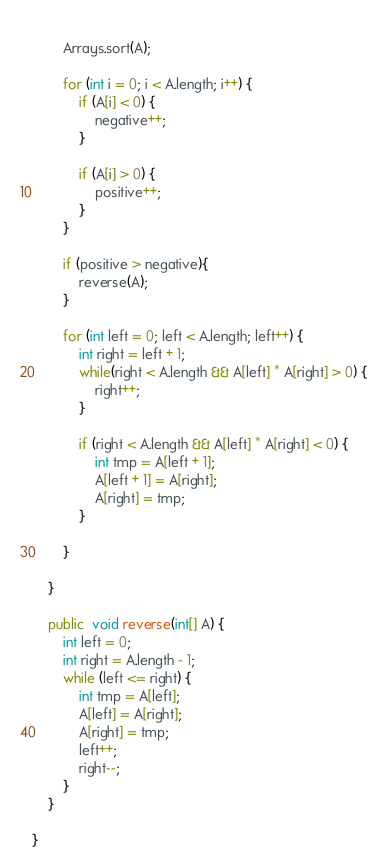<code> <loc_0><loc_0><loc_500><loc_500><_Java_>        
        Arrays.sort(A);

        for (int i = 0; i < A.length; i++) {
            if (A[i] < 0) {
                negative++;
            }

            if (A[i] > 0) {
                positive++;
            }
        }
        
        if (positive > negative){
            reverse(A);
        }

        for (int left = 0; left < A.length; left++) {
            int right = left + 1;
            while(right < A.length && A[left] * A[right] > 0) {
                right++;
            }
            
            if (right < A.length && A[left] * A[right] < 0) {
                int tmp = A[left + 1];
                A[left + 1] = A[right];
                A[right] = tmp;
            }

        }

    }

    public  void reverse(int[] A) {
        int left = 0;
        int right = A.length - 1;
        while (left <= right) {
            int tmp = A[left];
            A[left] = A[right];
            A[right] = tmp;
            left++;
            right--;
        }
    }

}</code> 